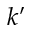Convert formula to latex. <formula><loc_0><loc_0><loc_500><loc_500>k ^ { \prime }</formula> 